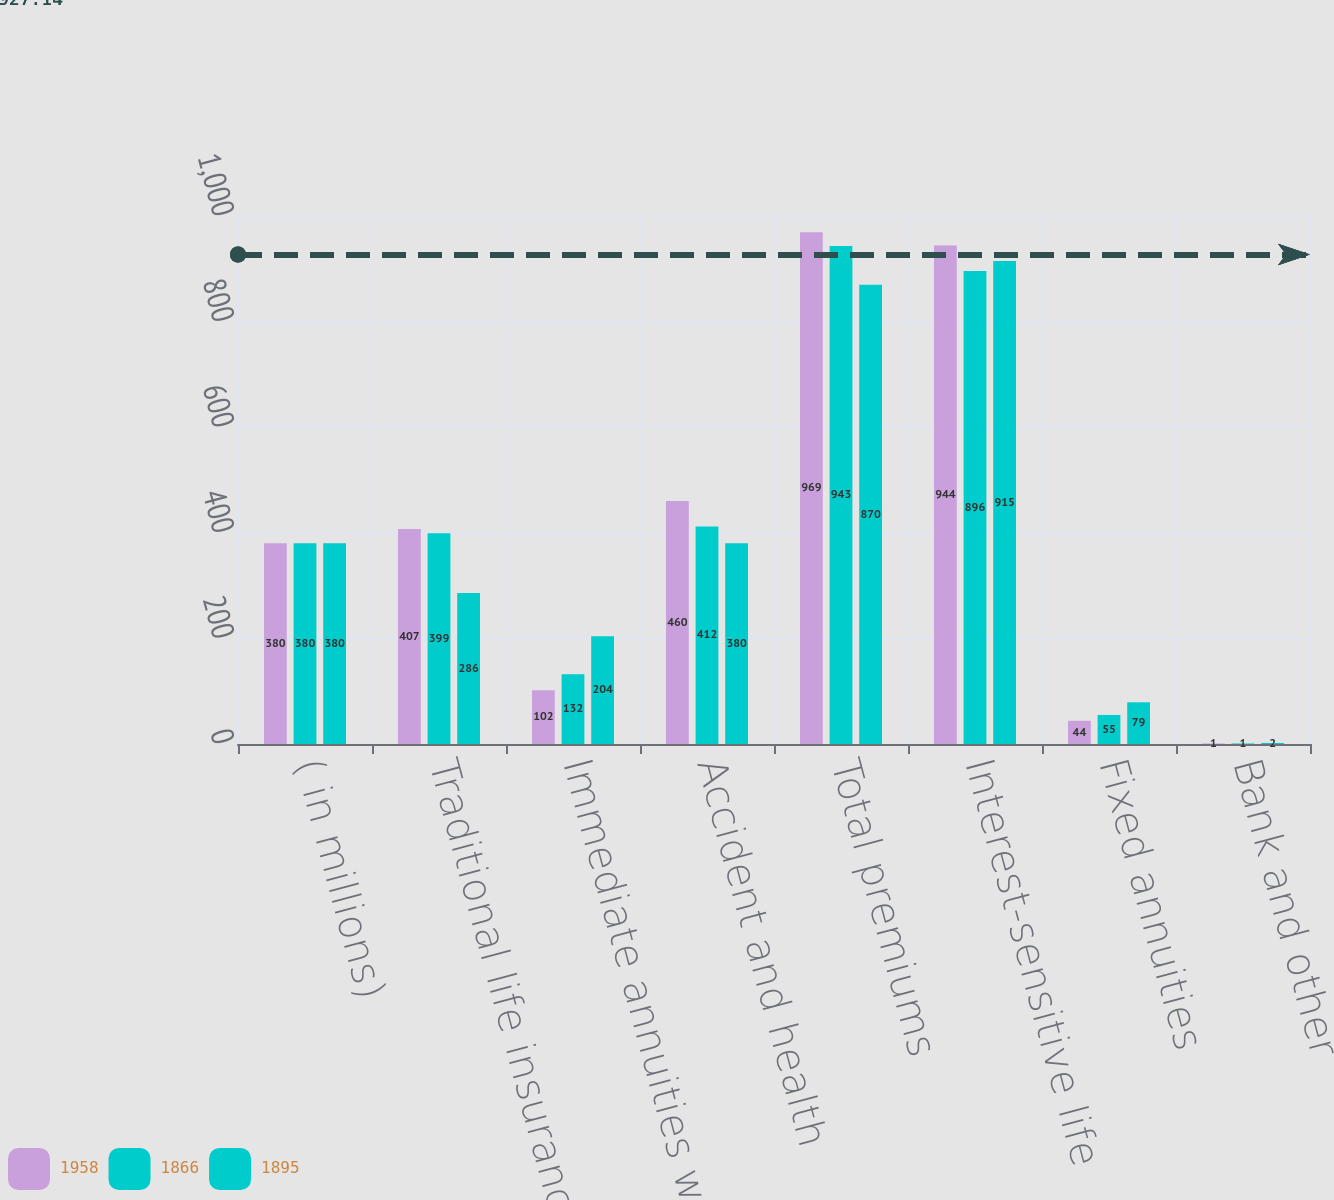Convert chart. <chart><loc_0><loc_0><loc_500><loc_500><stacked_bar_chart><ecel><fcel>( in millions)<fcel>Traditional life insurance (1)<fcel>Immediate annuities with life<fcel>Accident and health<fcel>Total premiums<fcel>Interest-sensitive life<fcel>Fixed annuities<fcel>Bank and other<nl><fcel>1958<fcel>380<fcel>407<fcel>102<fcel>460<fcel>969<fcel>944<fcel>44<fcel>1<nl><fcel>1866<fcel>380<fcel>399<fcel>132<fcel>412<fcel>943<fcel>896<fcel>55<fcel>1<nl><fcel>1895<fcel>380<fcel>286<fcel>204<fcel>380<fcel>870<fcel>915<fcel>79<fcel>2<nl></chart> 